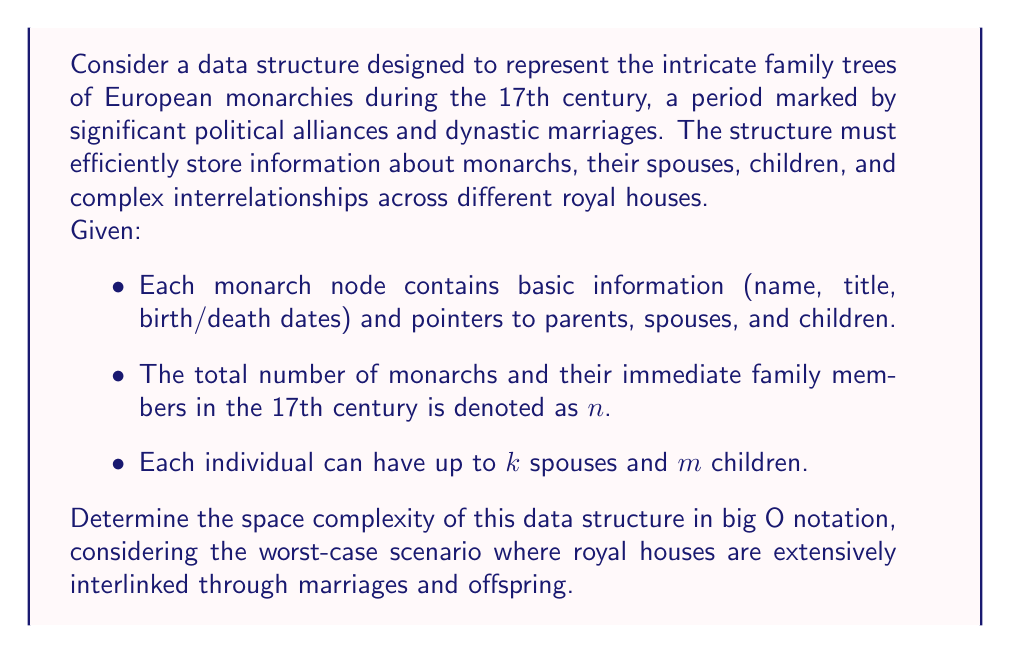Could you help me with this problem? To determine the space complexity, let's analyze the components of our data structure:

1. Basic information storage:
   - Each node stores a constant amount of data (name, title, dates), which we can consider $O(1)$ space.
   - Total space for basic information: $O(n)$

2. Relationship pointers:
   - Parents: Each node has at most 2 parent pointers.
   - Spouses: Each node can have up to $k$ spouse pointers.
   - Children: Each node can have up to $m$ child pointers.
   - Total pointers per node: $2 + k + m$
   - Space for pointers across all nodes: $O(n(2 + k + m))$

3. Overall space complexity:
   - Combining basic information and pointers: $O(n) + O(n(2 + k + m))$
   - Simplifying: $O(n(3 + k + m))$

4. Worst-case scenario:
   - In the 17th century, monarchs rarely had more than a few spouses or dozens of children.
   - We can consider $k$ and $m$ as constants, albeit potentially large ones.
   - Therefore, $O(n(3 + k + m))$ simplifies to $O(n)$

5. Additional considerations:
   - The interlinked nature of royal families doesn't increase the asymptotic space complexity.
   - Each relationship is represented by pointers, which are already accounted for in our calculation.

Thus, despite the complex nature of royal family trees and potential interlinking between houses, the space complexity remains linear with respect to the number of individuals in the data structure.
Answer: The space complexity of the data structure representing European monarchies' family trees is $O(n)$, where $n$ is the total number of monarchs and their immediate family members. 